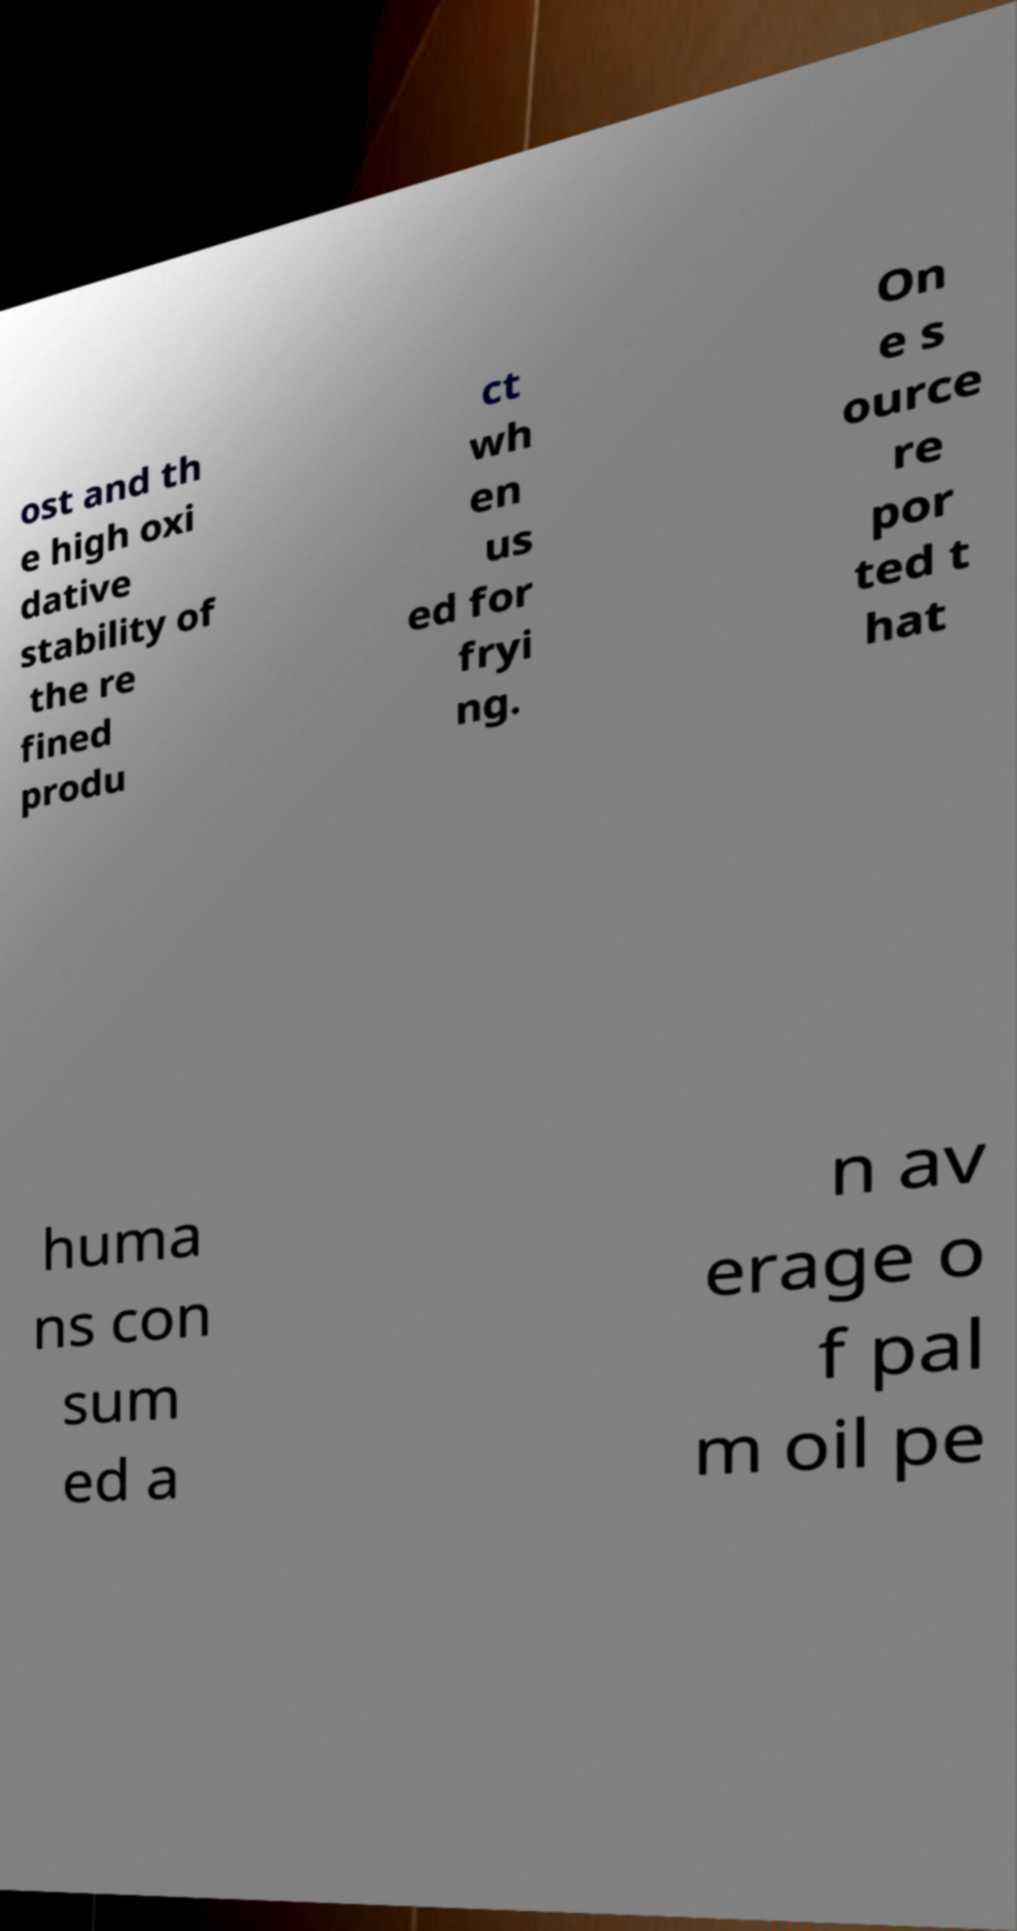Could you assist in decoding the text presented in this image and type it out clearly? ost and th e high oxi dative stability of the re fined produ ct wh en us ed for fryi ng. On e s ource re por ted t hat huma ns con sum ed a n av erage o f pal m oil pe 